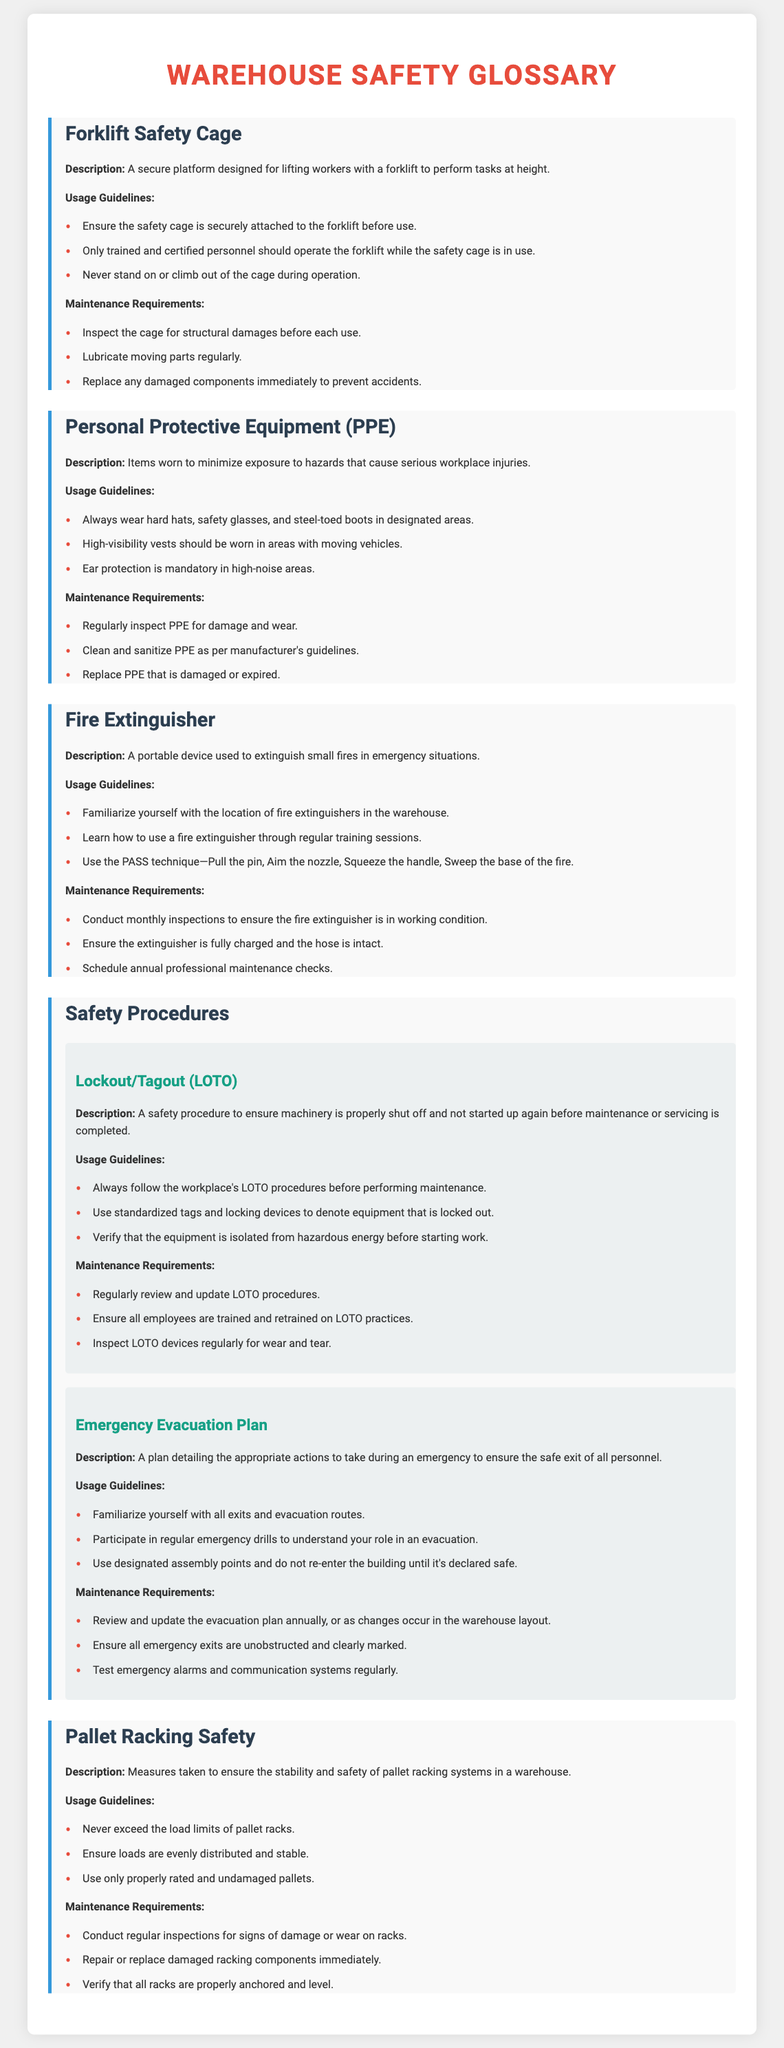What is the purpose of a Forklift Safety Cage? It is designed for lifting workers with a forklift to perform tasks at height.
Answer: Secure platform What are the mandatory items to be worn as PPE? The document specifies items like hard hats, safety glasses, and steel-toed boots.
Answer: Hard hats, safety glasses, steel-toed boots What does the acronym LOTO stand for? LOTO stands for Lockout/Tagout, which is a safety procedure.
Answer: Lockout/Tagout How often should fire extinguishers be inspected? The document mentions conducting monthly inspections for fire extinguishers.
Answer: Monthly What technique is used when operating a fire extinguisher? The technique described in the document is the PASS technique—Pull, Aim, Squeeze, Sweep.
Answer: PASS What is an essential safety procedure during emergencies? The document highlights the importance of an Emergency Evacuation Plan for safety during emergencies.
Answer: Emergency Evacuation Plan What should be done if a pallet rack is damaged? The document states that damaged racking components should be repaired or replaced immediately.
Answer: Repair or replace immediately What type of training is required for using a Forklift Safety Cage? Only trained and certified personnel should operate the forklift while using the safety cage.
Answer: Trained and certified personnel How often should the evacuation plan be reviewed? The document recommends reviewing and updating the evacuation plan annually.
Answer: Annually 